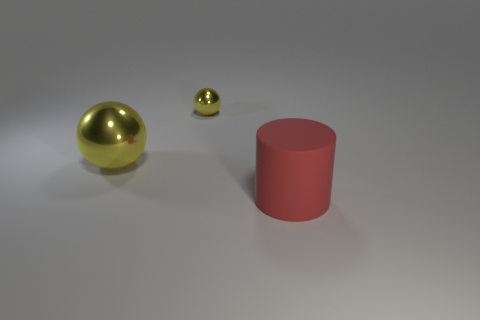What can you infer about the setting of these objects from the background? The setting is quite minimalist and neutral, with a background that doesn't offer context clues. It creates an impression of a controlled environment, likely a studio setup intended to focus attention solely on the objects without distractions. 